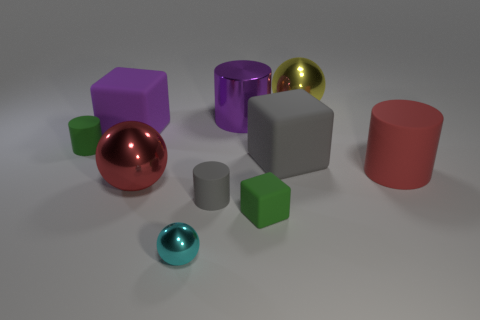Subtract all tiny green cylinders. How many cylinders are left? 3 Subtract all gray cylinders. How many cylinders are left? 3 Subtract all green balls. Subtract all brown cubes. How many balls are left? 3 Subtract all cylinders. How many objects are left? 6 Add 6 large gray cubes. How many large gray cubes exist? 7 Subtract 1 purple cylinders. How many objects are left? 9 Subtract all tiny brown cylinders. Subtract all green rubber blocks. How many objects are left? 9 Add 5 tiny gray objects. How many tiny gray objects are left? 6 